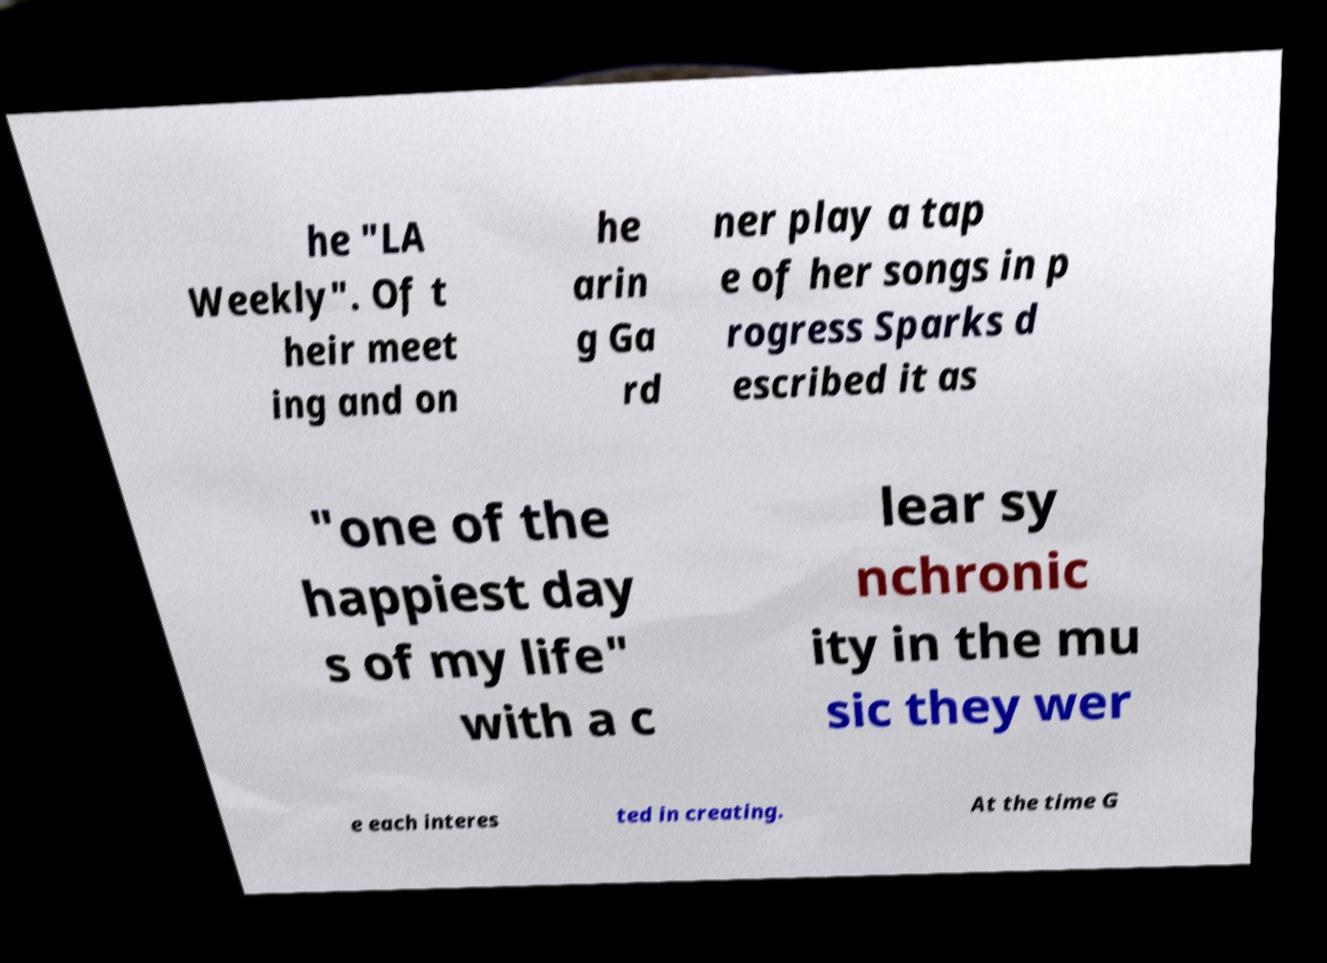Please identify and transcribe the text found in this image. he "LA Weekly". Of t heir meet ing and on he arin g Ga rd ner play a tap e of her songs in p rogress Sparks d escribed it as "one of the happiest day s of my life" with a c lear sy nchronic ity in the mu sic they wer e each interes ted in creating. At the time G 